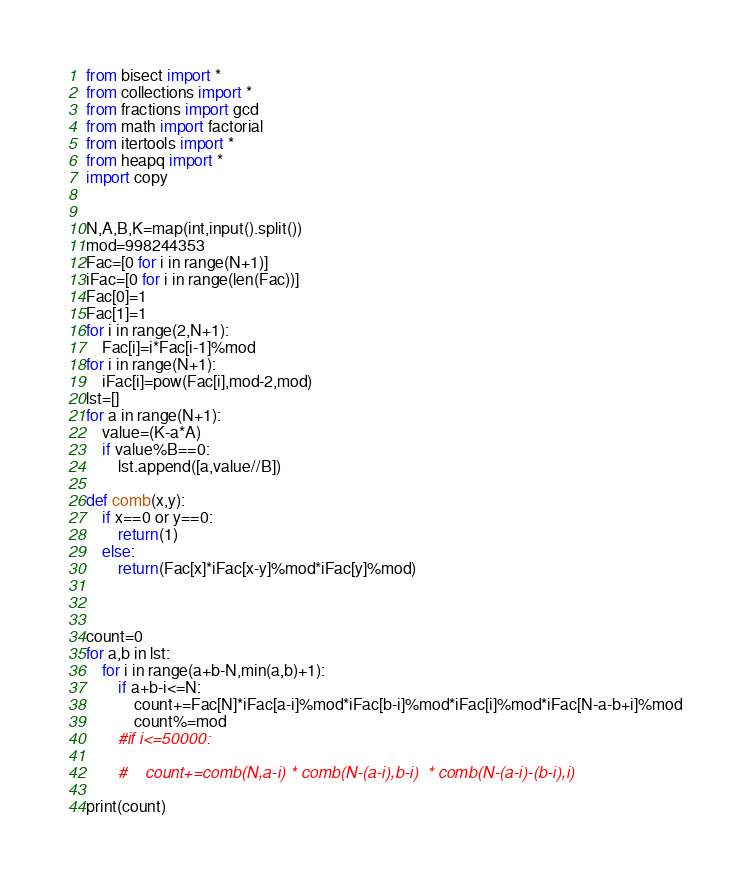<code> <loc_0><loc_0><loc_500><loc_500><_Python_>from bisect import *
from collections import *
from fractions import gcd
from math import factorial
from itertools import *
from heapq import *
import copy


N,A,B,K=map(int,input().split())
mod=998244353
Fac=[0 for i in range(N+1)]
iFac=[0 for i in range(len(Fac))]
Fac[0]=1
Fac[1]=1
for i in range(2,N+1):
    Fac[i]=i*Fac[i-1]%mod
for i in range(N+1):
    iFac[i]=pow(Fac[i],mod-2,mod)
lst=[]
for a in range(N+1):
    value=(K-a*A)
    if value%B==0:
        lst.append([a,value//B])

def comb(x,y):
    if x==0 or y==0:
        return(1)
    else:
        return(Fac[x]*iFac[x-y]%mod*iFac[y]%mod)



count=0
for a,b in lst:
    for i in range(a+b-N,min(a,b)+1):
        if a+b-i<=N:
            count+=Fac[N]*iFac[a-i]%mod*iFac[b-i]%mod*iFac[i]%mod*iFac[N-a-b+i]%mod
            count%=mod
        #if i<=50000:

        #    count+=comb(N,a-i) * comb(N-(a-i),b-i)  * comb(N-(a-i)-(b-i),i)

print(count)
</code> 